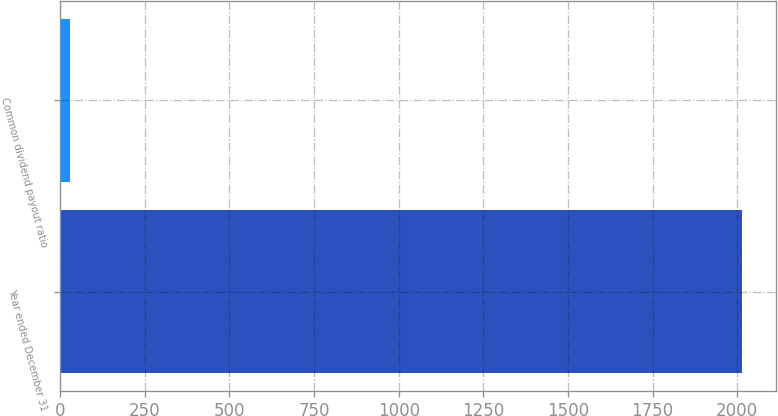Convert chart. <chart><loc_0><loc_0><loc_500><loc_500><bar_chart><fcel>Year ended December 31<fcel>Common dividend payout ratio<nl><fcel>2015<fcel>28<nl></chart> 